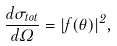<formula> <loc_0><loc_0><loc_500><loc_500>\frac { d \sigma _ { t o t } } { d \Omega } = | f ( \theta ) | ^ { 2 } ,</formula> 